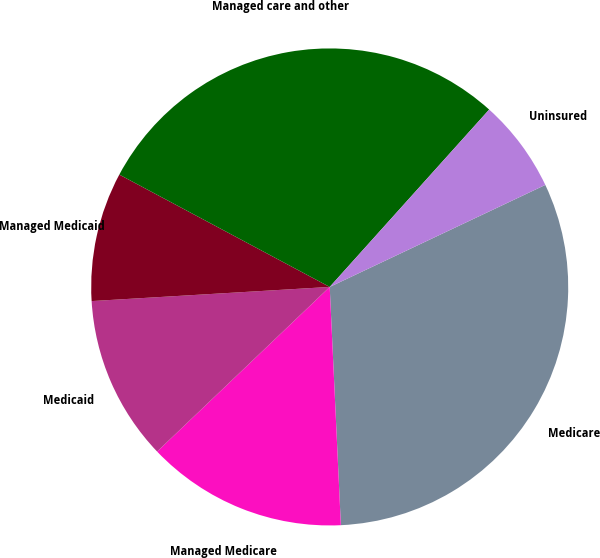<chart> <loc_0><loc_0><loc_500><loc_500><pie_chart><fcel>Medicare<fcel>Managed Medicare<fcel>Medicaid<fcel>Managed Medicaid<fcel>Managed care and other<fcel>Uninsured<nl><fcel>31.29%<fcel>13.62%<fcel>11.18%<fcel>8.75%<fcel>28.85%<fcel>6.31%<nl></chart> 